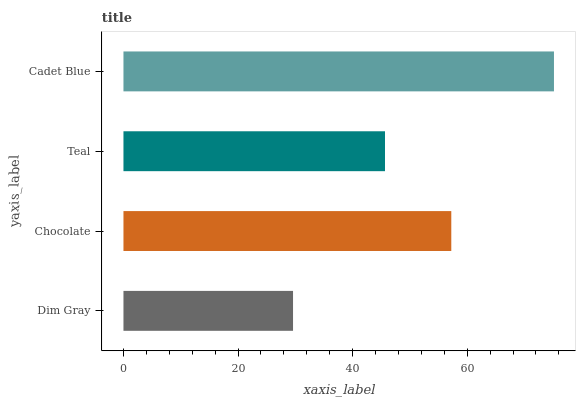Is Dim Gray the minimum?
Answer yes or no. Yes. Is Cadet Blue the maximum?
Answer yes or no. Yes. Is Chocolate the minimum?
Answer yes or no. No. Is Chocolate the maximum?
Answer yes or no. No. Is Chocolate greater than Dim Gray?
Answer yes or no. Yes. Is Dim Gray less than Chocolate?
Answer yes or no. Yes. Is Dim Gray greater than Chocolate?
Answer yes or no. No. Is Chocolate less than Dim Gray?
Answer yes or no. No. Is Chocolate the high median?
Answer yes or no. Yes. Is Teal the low median?
Answer yes or no. Yes. Is Teal the high median?
Answer yes or no. No. Is Dim Gray the low median?
Answer yes or no. No. 